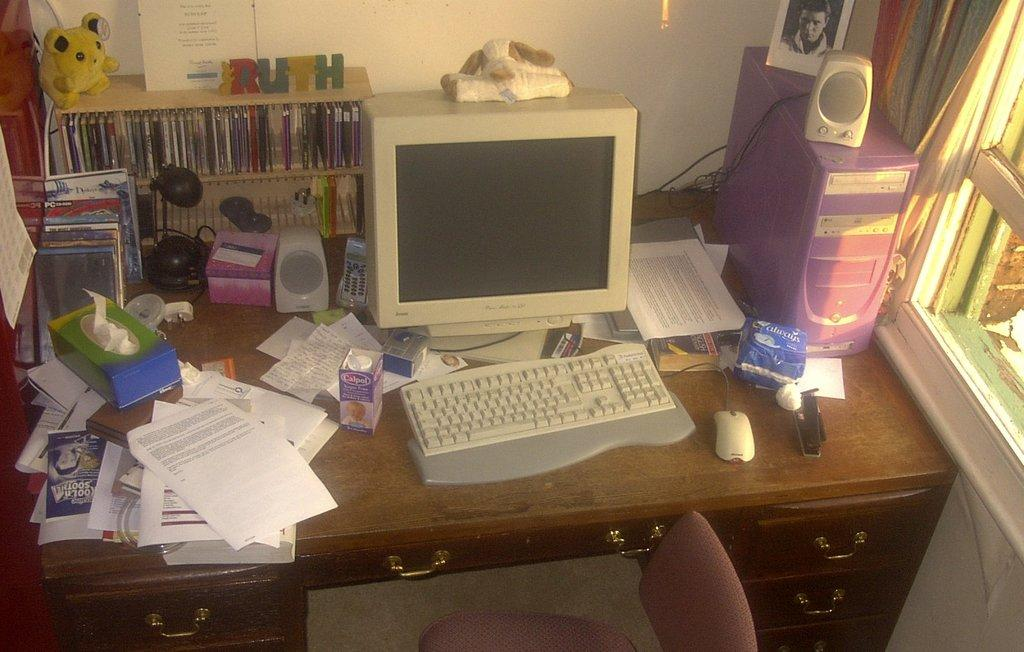<image>
Offer a succinct explanation of the picture presented. A computer desk filled with objects and a pack of feminine pads by Always beside the keyboard 